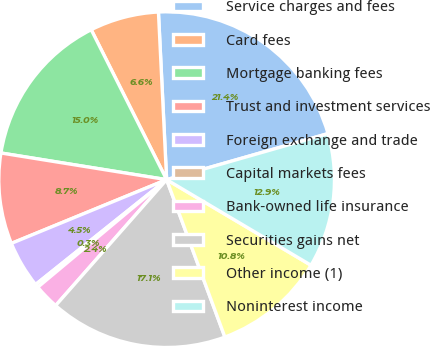Convert chart to OTSL. <chart><loc_0><loc_0><loc_500><loc_500><pie_chart><fcel>Service charges and fees<fcel>Card fees<fcel>Mortgage banking fees<fcel>Trust and investment services<fcel>Foreign exchange and trade<fcel>Capital markets fees<fcel>Bank-owned life insurance<fcel>Securities gains net<fcel>Other income (1)<fcel>Noninterest income<nl><fcel>21.35%<fcel>6.64%<fcel>15.04%<fcel>8.74%<fcel>4.54%<fcel>0.33%<fcel>2.43%<fcel>17.14%<fcel>10.84%<fcel>12.94%<nl></chart> 